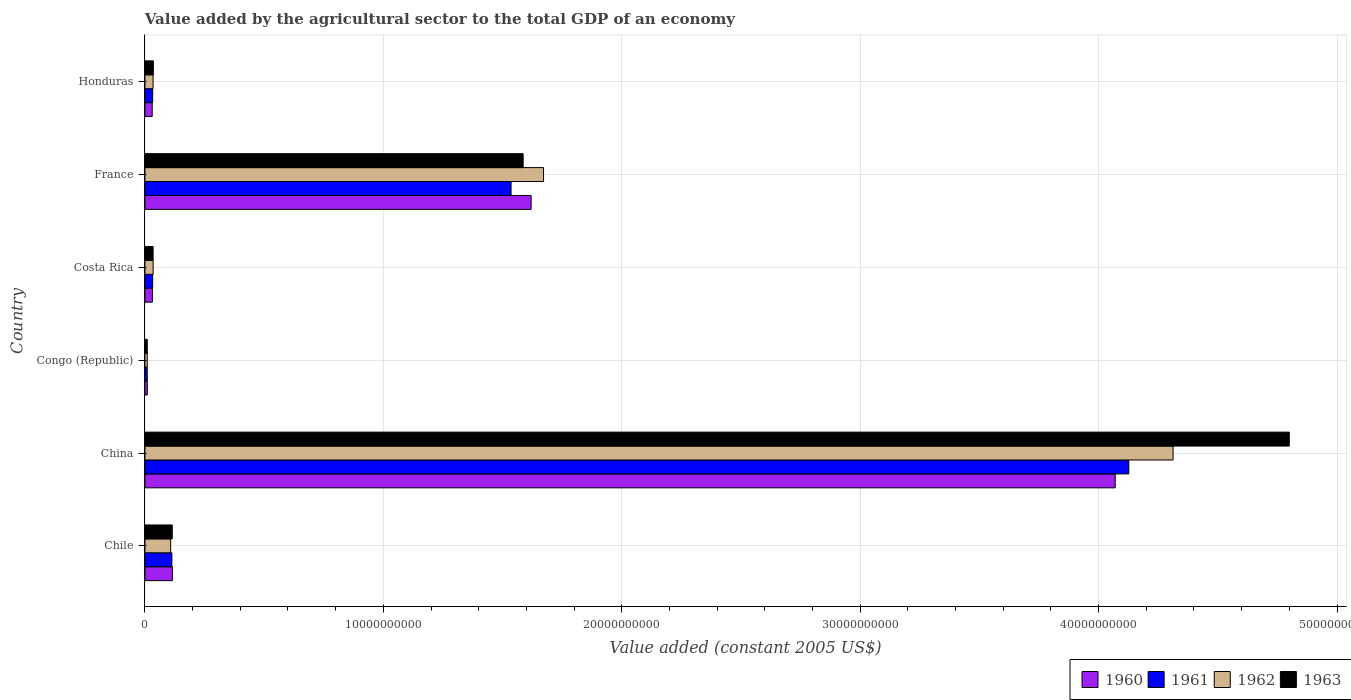Are the number of bars on each tick of the Y-axis equal?
Provide a short and direct response. Yes. How many bars are there on the 5th tick from the top?
Provide a succinct answer. 4. What is the label of the 5th group of bars from the top?
Provide a succinct answer. China. In how many cases, is the number of bars for a given country not equal to the number of legend labels?
Provide a succinct answer. 0. What is the value added by the agricultural sector in 1963 in Chile?
Your answer should be compact. 1.15e+09. Across all countries, what is the maximum value added by the agricultural sector in 1960?
Make the answer very short. 4.07e+1. Across all countries, what is the minimum value added by the agricultural sector in 1963?
Your answer should be very brief. 9.86e+07. In which country was the value added by the agricultural sector in 1960 minimum?
Your response must be concise. Congo (Republic). What is the total value added by the agricultural sector in 1961 in the graph?
Make the answer very short. 5.85e+1. What is the difference between the value added by the agricultural sector in 1962 in China and that in Congo (Republic)?
Your response must be concise. 4.30e+1. What is the difference between the value added by the agricultural sector in 1961 in Congo (Republic) and the value added by the agricultural sector in 1960 in Honduras?
Keep it short and to the point. -2.08e+08. What is the average value added by the agricultural sector in 1961 per country?
Offer a terse response. 9.75e+09. What is the difference between the value added by the agricultural sector in 1961 and value added by the agricultural sector in 1962 in Costa Rica?
Your answer should be compact. -1.99e+07. What is the ratio of the value added by the agricultural sector in 1960 in Costa Rica to that in France?
Ensure brevity in your answer.  0.02. What is the difference between the highest and the second highest value added by the agricultural sector in 1963?
Ensure brevity in your answer.  3.21e+1. What is the difference between the highest and the lowest value added by the agricultural sector in 1961?
Give a very brief answer. 4.12e+1. Is it the case that in every country, the sum of the value added by the agricultural sector in 1961 and value added by the agricultural sector in 1960 is greater than the sum of value added by the agricultural sector in 1963 and value added by the agricultural sector in 1962?
Provide a short and direct response. No. What does the 2nd bar from the top in Chile represents?
Ensure brevity in your answer.  1962. Is it the case that in every country, the sum of the value added by the agricultural sector in 1960 and value added by the agricultural sector in 1963 is greater than the value added by the agricultural sector in 1961?
Your answer should be very brief. Yes. How many bars are there?
Your response must be concise. 24. Are all the bars in the graph horizontal?
Your answer should be compact. Yes. Does the graph contain any zero values?
Offer a very short reply. No. How many legend labels are there?
Your response must be concise. 4. How are the legend labels stacked?
Offer a very short reply. Horizontal. What is the title of the graph?
Your answer should be compact. Value added by the agricultural sector to the total GDP of an economy. Does "1971" appear as one of the legend labels in the graph?
Your answer should be very brief. No. What is the label or title of the X-axis?
Your answer should be very brief. Value added (constant 2005 US$). What is the Value added (constant 2005 US$) in 1960 in Chile?
Your answer should be compact. 1.15e+09. What is the Value added (constant 2005 US$) of 1961 in Chile?
Ensure brevity in your answer.  1.13e+09. What is the Value added (constant 2005 US$) in 1962 in Chile?
Your response must be concise. 1.08e+09. What is the Value added (constant 2005 US$) in 1963 in Chile?
Give a very brief answer. 1.15e+09. What is the Value added (constant 2005 US$) in 1960 in China?
Keep it short and to the point. 4.07e+1. What is the Value added (constant 2005 US$) of 1961 in China?
Ensure brevity in your answer.  4.13e+1. What is the Value added (constant 2005 US$) of 1962 in China?
Offer a very short reply. 4.31e+1. What is the Value added (constant 2005 US$) in 1963 in China?
Offer a terse response. 4.80e+1. What is the Value added (constant 2005 US$) in 1960 in Congo (Republic)?
Offer a very short reply. 1.01e+08. What is the Value added (constant 2005 US$) of 1961 in Congo (Republic)?
Offer a very short reply. 9.74e+07. What is the Value added (constant 2005 US$) in 1962 in Congo (Republic)?
Offer a very short reply. 9.79e+07. What is the Value added (constant 2005 US$) of 1963 in Congo (Republic)?
Make the answer very short. 9.86e+07. What is the Value added (constant 2005 US$) in 1960 in Costa Rica?
Your answer should be very brief. 3.13e+08. What is the Value added (constant 2005 US$) of 1961 in Costa Rica?
Offer a terse response. 3.24e+08. What is the Value added (constant 2005 US$) in 1962 in Costa Rica?
Make the answer very short. 3.44e+08. What is the Value added (constant 2005 US$) of 1963 in Costa Rica?
Your answer should be very brief. 3.43e+08. What is the Value added (constant 2005 US$) of 1960 in France?
Your answer should be very brief. 1.62e+1. What is the Value added (constant 2005 US$) of 1961 in France?
Give a very brief answer. 1.54e+1. What is the Value added (constant 2005 US$) of 1962 in France?
Your answer should be compact. 1.67e+1. What is the Value added (constant 2005 US$) of 1963 in France?
Offer a terse response. 1.59e+1. What is the Value added (constant 2005 US$) in 1960 in Honduras?
Provide a succinct answer. 3.05e+08. What is the Value added (constant 2005 US$) of 1961 in Honduras?
Provide a short and direct response. 3.25e+08. What is the Value added (constant 2005 US$) of 1962 in Honduras?
Provide a short and direct response. 3.41e+08. What is the Value added (constant 2005 US$) in 1963 in Honduras?
Make the answer very short. 3.53e+08. Across all countries, what is the maximum Value added (constant 2005 US$) in 1960?
Offer a terse response. 4.07e+1. Across all countries, what is the maximum Value added (constant 2005 US$) of 1961?
Keep it short and to the point. 4.13e+1. Across all countries, what is the maximum Value added (constant 2005 US$) in 1962?
Offer a terse response. 4.31e+1. Across all countries, what is the maximum Value added (constant 2005 US$) of 1963?
Give a very brief answer. 4.80e+1. Across all countries, what is the minimum Value added (constant 2005 US$) of 1960?
Make the answer very short. 1.01e+08. Across all countries, what is the minimum Value added (constant 2005 US$) of 1961?
Offer a terse response. 9.74e+07. Across all countries, what is the minimum Value added (constant 2005 US$) of 1962?
Give a very brief answer. 9.79e+07. Across all countries, what is the minimum Value added (constant 2005 US$) of 1963?
Your response must be concise. 9.86e+07. What is the total Value added (constant 2005 US$) of 1960 in the graph?
Your answer should be compact. 5.88e+1. What is the total Value added (constant 2005 US$) of 1961 in the graph?
Keep it short and to the point. 5.85e+1. What is the total Value added (constant 2005 US$) of 1962 in the graph?
Your answer should be very brief. 6.17e+1. What is the total Value added (constant 2005 US$) in 1963 in the graph?
Provide a succinct answer. 6.58e+1. What is the difference between the Value added (constant 2005 US$) in 1960 in Chile and that in China?
Provide a succinct answer. -3.95e+1. What is the difference between the Value added (constant 2005 US$) of 1961 in Chile and that in China?
Your answer should be compact. -4.01e+1. What is the difference between the Value added (constant 2005 US$) in 1962 in Chile and that in China?
Make the answer very short. -4.20e+1. What is the difference between the Value added (constant 2005 US$) of 1963 in Chile and that in China?
Make the answer very short. -4.69e+1. What is the difference between the Value added (constant 2005 US$) of 1960 in Chile and that in Congo (Republic)?
Provide a short and direct response. 1.05e+09. What is the difference between the Value added (constant 2005 US$) of 1961 in Chile and that in Congo (Republic)?
Keep it short and to the point. 1.03e+09. What is the difference between the Value added (constant 2005 US$) of 1962 in Chile and that in Congo (Republic)?
Provide a short and direct response. 9.81e+08. What is the difference between the Value added (constant 2005 US$) in 1963 in Chile and that in Congo (Republic)?
Keep it short and to the point. 1.05e+09. What is the difference between the Value added (constant 2005 US$) in 1960 in Chile and that in Costa Rica?
Your answer should be very brief. 8.39e+08. What is the difference between the Value added (constant 2005 US$) of 1961 in Chile and that in Costa Rica?
Keep it short and to the point. 8.06e+08. What is the difference between the Value added (constant 2005 US$) of 1962 in Chile and that in Costa Rica?
Give a very brief answer. 7.35e+08. What is the difference between the Value added (constant 2005 US$) in 1963 in Chile and that in Costa Rica?
Your response must be concise. 8.03e+08. What is the difference between the Value added (constant 2005 US$) in 1960 in Chile and that in France?
Ensure brevity in your answer.  -1.50e+1. What is the difference between the Value added (constant 2005 US$) in 1961 in Chile and that in France?
Your answer should be very brief. -1.42e+1. What is the difference between the Value added (constant 2005 US$) of 1962 in Chile and that in France?
Your response must be concise. -1.56e+1. What is the difference between the Value added (constant 2005 US$) in 1963 in Chile and that in France?
Offer a very short reply. -1.47e+1. What is the difference between the Value added (constant 2005 US$) of 1960 in Chile and that in Honduras?
Make the answer very short. 8.46e+08. What is the difference between the Value added (constant 2005 US$) in 1961 in Chile and that in Honduras?
Ensure brevity in your answer.  8.05e+08. What is the difference between the Value added (constant 2005 US$) of 1962 in Chile and that in Honduras?
Ensure brevity in your answer.  7.38e+08. What is the difference between the Value added (constant 2005 US$) of 1963 in Chile and that in Honduras?
Keep it short and to the point. 7.93e+08. What is the difference between the Value added (constant 2005 US$) in 1960 in China and that in Congo (Republic)?
Your response must be concise. 4.06e+1. What is the difference between the Value added (constant 2005 US$) in 1961 in China and that in Congo (Republic)?
Keep it short and to the point. 4.12e+1. What is the difference between the Value added (constant 2005 US$) in 1962 in China and that in Congo (Republic)?
Provide a succinct answer. 4.30e+1. What is the difference between the Value added (constant 2005 US$) of 1963 in China and that in Congo (Republic)?
Offer a very short reply. 4.79e+1. What is the difference between the Value added (constant 2005 US$) in 1960 in China and that in Costa Rica?
Give a very brief answer. 4.04e+1. What is the difference between the Value added (constant 2005 US$) of 1961 in China and that in Costa Rica?
Offer a terse response. 4.09e+1. What is the difference between the Value added (constant 2005 US$) in 1962 in China and that in Costa Rica?
Ensure brevity in your answer.  4.28e+1. What is the difference between the Value added (constant 2005 US$) in 1963 in China and that in Costa Rica?
Your answer should be very brief. 4.77e+1. What is the difference between the Value added (constant 2005 US$) of 1960 in China and that in France?
Your answer should be compact. 2.45e+1. What is the difference between the Value added (constant 2005 US$) of 1961 in China and that in France?
Make the answer very short. 2.59e+1. What is the difference between the Value added (constant 2005 US$) of 1962 in China and that in France?
Your answer should be compact. 2.64e+1. What is the difference between the Value added (constant 2005 US$) in 1963 in China and that in France?
Your response must be concise. 3.21e+1. What is the difference between the Value added (constant 2005 US$) of 1960 in China and that in Honduras?
Keep it short and to the point. 4.04e+1. What is the difference between the Value added (constant 2005 US$) in 1961 in China and that in Honduras?
Make the answer very short. 4.09e+1. What is the difference between the Value added (constant 2005 US$) of 1962 in China and that in Honduras?
Ensure brevity in your answer.  4.28e+1. What is the difference between the Value added (constant 2005 US$) of 1963 in China and that in Honduras?
Provide a short and direct response. 4.76e+1. What is the difference between the Value added (constant 2005 US$) in 1960 in Congo (Republic) and that in Costa Rica?
Provide a short and direct response. -2.12e+08. What is the difference between the Value added (constant 2005 US$) in 1961 in Congo (Republic) and that in Costa Rica?
Make the answer very short. -2.27e+08. What is the difference between the Value added (constant 2005 US$) of 1962 in Congo (Republic) and that in Costa Rica?
Provide a succinct answer. -2.46e+08. What is the difference between the Value added (constant 2005 US$) of 1963 in Congo (Republic) and that in Costa Rica?
Your response must be concise. -2.45e+08. What is the difference between the Value added (constant 2005 US$) in 1960 in Congo (Republic) and that in France?
Offer a very short reply. -1.61e+1. What is the difference between the Value added (constant 2005 US$) of 1961 in Congo (Republic) and that in France?
Keep it short and to the point. -1.53e+1. What is the difference between the Value added (constant 2005 US$) of 1962 in Congo (Republic) and that in France?
Give a very brief answer. -1.66e+1. What is the difference between the Value added (constant 2005 US$) in 1963 in Congo (Republic) and that in France?
Provide a short and direct response. -1.58e+1. What is the difference between the Value added (constant 2005 US$) of 1960 in Congo (Republic) and that in Honduras?
Offer a very short reply. -2.04e+08. What is the difference between the Value added (constant 2005 US$) of 1961 in Congo (Republic) and that in Honduras?
Offer a very short reply. -2.28e+08. What is the difference between the Value added (constant 2005 US$) of 1962 in Congo (Republic) and that in Honduras?
Offer a terse response. -2.43e+08. What is the difference between the Value added (constant 2005 US$) in 1963 in Congo (Republic) and that in Honduras?
Keep it short and to the point. -2.55e+08. What is the difference between the Value added (constant 2005 US$) of 1960 in Costa Rica and that in France?
Make the answer very short. -1.59e+1. What is the difference between the Value added (constant 2005 US$) in 1961 in Costa Rica and that in France?
Ensure brevity in your answer.  -1.50e+1. What is the difference between the Value added (constant 2005 US$) in 1962 in Costa Rica and that in France?
Your answer should be compact. -1.64e+1. What is the difference between the Value added (constant 2005 US$) in 1963 in Costa Rica and that in France?
Your response must be concise. -1.55e+1. What is the difference between the Value added (constant 2005 US$) of 1960 in Costa Rica and that in Honduras?
Provide a short and direct response. 7.61e+06. What is the difference between the Value added (constant 2005 US$) of 1961 in Costa Rica and that in Honduras?
Offer a terse response. -8.14e+05. What is the difference between the Value added (constant 2005 US$) of 1962 in Costa Rica and that in Honduras?
Offer a terse response. 3.61e+06. What is the difference between the Value added (constant 2005 US$) in 1963 in Costa Rica and that in Honduras?
Your response must be concise. -9.78e+06. What is the difference between the Value added (constant 2005 US$) in 1960 in France and that in Honduras?
Keep it short and to the point. 1.59e+1. What is the difference between the Value added (constant 2005 US$) in 1961 in France and that in Honduras?
Provide a succinct answer. 1.50e+1. What is the difference between the Value added (constant 2005 US$) in 1962 in France and that in Honduras?
Keep it short and to the point. 1.64e+1. What is the difference between the Value added (constant 2005 US$) of 1963 in France and that in Honduras?
Ensure brevity in your answer.  1.55e+1. What is the difference between the Value added (constant 2005 US$) in 1960 in Chile and the Value added (constant 2005 US$) in 1961 in China?
Offer a very short reply. -4.01e+1. What is the difference between the Value added (constant 2005 US$) in 1960 in Chile and the Value added (constant 2005 US$) in 1962 in China?
Ensure brevity in your answer.  -4.20e+1. What is the difference between the Value added (constant 2005 US$) of 1960 in Chile and the Value added (constant 2005 US$) of 1963 in China?
Make the answer very short. -4.68e+1. What is the difference between the Value added (constant 2005 US$) in 1961 in Chile and the Value added (constant 2005 US$) in 1962 in China?
Offer a terse response. -4.20e+1. What is the difference between the Value added (constant 2005 US$) in 1961 in Chile and the Value added (constant 2005 US$) in 1963 in China?
Your answer should be very brief. -4.69e+1. What is the difference between the Value added (constant 2005 US$) in 1962 in Chile and the Value added (constant 2005 US$) in 1963 in China?
Your answer should be very brief. -4.69e+1. What is the difference between the Value added (constant 2005 US$) in 1960 in Chile and the Value added (constant 2005 US$) in 1961 in Congo (Republic)?
Your response must be concise. 1.05e+09. What is the difference between the Value added (constant 2005 US$) in 1960 in Chile and the Value added (constant 2005 US$) in 1962 in Congo (Republic)?
Provide a succinct answer. 1.05e+09. What is the difference between the Value added (constant 2005 US$) of 1960 in Chile and the Value added (constant 2005 US$) of 1963 in Congo (Republic)?
Provide a short and direct response. 1.05e+09. What is the difference between the Value added (constant 2005 US$) in 1961 in Chile and the Value added (constant 2005 US$) in 1962 in Congo (Republic)?
Your answer should be compact. 1.03e+09. What is the difference between the Value added (constant 2005 US$) in 1961 in Chile and the Value added (constant 2005 US$) in 1963 in Congo (Republic)?
Give a very brief answer. 1.03e+09. What is the difference between the Value added (constant 2005 US$) in 1962 in Chile and the Value added (constant 2005 US$) in 1963 in Congo (Republic)?
Your response must be concise. 9.81e+08. What is the difference between the Value added (constant 2005 US$) of 1960 in Chile and the Value added (constant 2005 US$) of 1961 in Costa Rica?
Keep it short and to the point. 8.27e+08. What is the difference between the Value added (constant 2005 US$) of 1960 in Chile and the Value added (constant 2005 US$) of 1962 in Costa Rica?
Your answer should be very brief. 8.07e+08. What is the difference between the Value added (constant 2005 US$) in 1960 in Chile and the Value added (constant 2005 US$) in 1963 in Costa Rica?
Make the answer very short. 8.08e+08. What is the difference between the Value added (constant 2005 US$) of 1961 in Chile and the Value added (constant 2005 US$) of 1962 in Costa Rica?
Provide a succinct answer. 7.86e+08. What is the difference between the Value added (constant 2005 US$) in 1961 in Chile and the Value added (constant 2005 US$) in 1963 in Costa Rica?
Give a very brief answer. 7.87e+08. What is the difference between the Value added (constant 2005 US$) in 1962 in Chile and the Value added (constant 2005 US$) in 1963 in Costa Rica?
Provide a short and direct response. 7.36e+08. What is the difference between the Value added (constant 2005 US$) of 1960 in Chile and the Value added (constant 2005 US$) of 1961 in France?
Offer a very short reply. -1.42e+1. What is the difference between the Value added (constant 2005 US$) in 1960 in Chile and the Value added (constant 2005 US$) in 1962 in France?
Give a very brief answer. -1.56e+1. What is the difference between the Value added (constant 2005 US$) of 1960 in Chile and the Value added (constant 2005 US$) of 1963 in France?
Your answer should be very brief. -1.47e+1. What is the difference between the Value added (constant 2005 US$) of 1961 in Chile and the Value added (constant 2005 US$) of 1962 in France?
Provide a succinct answer. -1.56e+1. What is the difference between the Value added (constant 2005 US$) in 1961 in Chile and the Value added (constant 2005 US$) in 1963 in France?
Your answer should be compact. -1.47e+1. What is the difference between the Value added (constant 2005 US$) of 1962 in Chile and the Value added (constant 2005 US$) of 1963 in France?
Give a very brief answer. -1.48e+1. What is the difference between the Value added (constant 2005 US$) in 1960 in Chile and the Value added (constant 2005 US$) in 1961 in Honduras?
Provide a short and direct response. 8.27e+08. What is the difference between the Value added (constant 2005 US$) in 1960 in Chile and the Value added (constant 2005 US$) in 1962 in Honduras?
Your response must be concise. 8.11e+08. What is the difference between the Value added (constant 2005 US$) of 1960 in Chile and the Value added (constant 2005 US$) of 1963 in Honduras?
Your answer should be compact. 7.99e+08. What is the difference between the Value added (constant 2005 US$) of 1961 in Chile and the Value added (constant 2005 US$) of 1962 in Honduras?
Provide a short and direct response. 7.90e+08. What is the difference between the Value added (constant 2005 US$) of 1961 in Chile and the Value added (constant 2005 US$) of 1963 in Honduras?
Provide a succinct answer. 7.78e+08. What is the difference between the Value added (constant 2005 US$) of 1962 in Chile and the Value added (constant 2005 US$) of 1963 in Honduras?
Ensure brevity in your answer.  7.26e+08. What is the difference between the Value added (constant 2005 US$) in 1960 in China and the Value added (constant 2005 US$) in 1961 in Congo (Republic)?
Keep it short and to the point. 4.06e+1. What is the difference between the Value added (constant 2005 US$) of 1960 in China and the Value added (constant 2005 US$) of 1962 in Congo (Republic)?
Your answer should be compact. 4.06e+1. What is the difference between the Value added (constant 2005 US$) in 1960 in China and the Value added (constant 2005 US$) in 1963 in Congo (Republic)?
Give a very brief answer. 4.06e+1. What is the difference between the Value added (constant 2005 US$) in 1961 in China and the Value added (constant 2005 US$) in 1962 in Congo (Republic)?
Provide a succinct answer. 4.12e+1. What is the difference between the Value added (constant 2005 US$) of 1961 in China and the Value added (constant 2005 US$) of 1963 in Congo (Republic)?
Ensure brevity in your answer.  4.12e+1. What is the difference between the Value added (constant 2005 US$) in 1962 in China and the Value added (constant 2005 US$) in 1963 in Congo (Republic)?
Ensure brevity in your answer.  4.30e+1. What is the difference between the Value added (constant 2005 US$) in 1960 in China and the Value added (constant 2005 US$) in 1961 in Costa Rica?
Make the answer very short. 4.04e+1. What is the difference between the Value added (constant 2005 US$) in 1960 in China and the Value added (constant 2005 US$) in 1962 in Costa Rica?
Your answer should be very brief. 4.04e+1. What is the difference between the Value added (constant 2005 US$) in 1960 in China and the Value added (constant 2005 US$) in 1963 in Costa Rica?
Your answer should be very brief. 4.04e+1. What is the difference between the Value added (constant 2005 US$) in 1961 in China and the Value added (constant 2005 US$) in 1962 in Costa Rica?
Give a very brief answer. 4.09e+1. What is the difference between the Value added (constant 2005 US$) in 1961 in China and the Value added (constant 2005 US$) in 1963 in Costa Rica?
Offer a terse response. 4.09e+1. What is the difference between the Value added (constant 2005 US$) of 1962 in China and the Value added (constant 2005 US$) of 1963 in Costa Rica?
Your answer should be compact. 4.28e+1. What is the difference between the Value added (constant 2005 US$) of 1960 in China and the Value added (constant 2005 US$) of 1961 in France?
Keep it short and to the point. 2.53e+1. What is the difference between the Value added (constant 2005 US$) of 1960 in China and the Value added (constant 2005 US$) of 1962 in France?
Your answer should be compact. 2.40e+1. What is the difference between the Value added (constant 2005 US$) of 1960 in China and the Value added (constant 2005 US$) of 1963 in France?
Provide a short and direct response. 2.48e+1. What is the difference between the Value added (constant 2005 US$) in 1961 in China and the Value added (constant 2005 US$) in 1962 in France?
Your answer should be very brief. 2.45e+1. What is the difference between the Value added (constant 2005 US$) in 1961 in China and the Value added (constant 2005 US$) in 1963 in France?
Provide a short and direct response. 2.54e+1. What is the difference between the Value added (constant 2005 US$) in 1962 in China and the Value added (constant 2005 US$) in 1963 in France?
Provide a short and direct response. 2.73e+1. What is the difference between the Value added (constant 2005 US$) of 1960 in China and the Value added (constant 2005 US$) of 1961 in Honduras?
Your answer should be compact. 4.04e+1. What is the difference between the Value added (constant 2005 US$) in 1960 in China and the Value added (constant 2005 US$) in 1962 in Honduras?
Your response must be concise. 4.04e+1. What is the difference between the Value added (constant 2005 US$) in 1960 in China and the Value added (constant 2005 US$) in 1963 in Honduras?
Offer a terse response. 4.03e+1. What is the difference between the Value added (constant 2005 US$) of 1961 in China and the Value added (constant 2005 US$) of 1962 in Honduras?
Keep it short and to the point. 4.09e+1. What is the difference between the Value added (constant 2005 US$) in 1961 in China and the Value added (constant 2005 US$) in 1963 in Honduras?
Provide a short and direct response. 4.09e+1. What is the difference between the Value added (constant 2005 US$) of 1962 in China and the Value added (constant 2005 US$) of 1963 in Honduras?
Offer a very short reply. 4.28e+1. What is the difference between the Value added (constant 2005 US$) of 1960 in Congo (Republic) and the Value added (constant 2005 US$) of 1961 in Costa Rica?
Your answer should be very brief. -2.24e+08. What is the difference between the Value added (constant 2005 US$) in 1960 in Congo (Republic) and the Value added (constant 2005 US$) in 1962 in Costa Rica?
Your answer should be very brief. -2.43e+08. What is the difference between the Value added (constant 2005 US$) of 1960 in Congo (Republic) and the Value added (constant 2005 US$) of 1963 in Costa Rica?
Your response must be concise. -2.42e+08. What is the difference between the Value added (constant 2005 US$) in 1961 in Congo (Republic) and the Value added (constant 2005 US$) in 1962 in Costa Rica?
Provide a succinct answer. -2.47e+08. What is the difference between the Value added (constant 2005 US$) in 1961 in Congo (Republic) and the Value added (constant 2005 US$) in 1963 in Costa Rica?
Give a very brief answer. -2.46e+08. What is the difference between the Value added (constant 2005 US$) in 1962 in Congo (Republic) and the Value added (constant 2005 US$) in 1963 in Costa Rica?
Offer a very short reply. -2.45e+08. What is the difference between the Value added (constant 2005 US$) in 1960 in Congo (Republic) and the Value added (constant 2005 US$) in 1961 in France?
Keep it short and to the point. -1.53e+1. What is the difference between the Value added (constant 2005 US$) of 1960 in Congo (Republic) and the Value added (constant 2005 US$) of 1962 in France?
Ensure brevity in your answer.  -1.66e+1. What is the difference between the Value added (constant 2005 US$) in 1960 in Congo (Republic) and the Value added (constant 2005 US$) in 1963 in France?
Give a very brief answer. -1.58e+1. What is the difference between the Value added (constant 2005 US$) in 1961 in Congo (Republic) and the Value added (constant 2005 US$) in 1962 in France?
Your response must be concise. -1.66e+1. What is the difference between the Value added (constant 2005 US$) in 1961 in Congo (Republic) and the Value added (constant 2005 US$) in 1963 in France?
Offer a terse response. -1.58e+1. What is the difference between the Value added (constant 2005 US$) of 1962 in Congo (Republic) and the Value added (constant 2005 US$) of 1963 in France?
Provide a short and direct response. -1.58e+1. What is the difference between the Value added (constant 2005 US$) in 1960 in Congo (Republic) and the Value added (constant 2005 US$) in 1961 in Honduras?
Keep it short and to the point. -2.24e+08. What is the difference between the Value added (constant 2005 US$) of 1960 in Congo (Republic) and the Value added (constant 2005 US$) of 1962 in Honduras?
Ensure brevity in your answer.  -2.40e+08. What is the difference between the Value added (constant 2005 US$) in 1960 in Congo (Republic) and the Value added (constant 2005 US$) in 1963 in Honduras?
Provide a short and direct response. -2.52e+08. What is the difference between the Value added (constant 2005 US$) of 1961 in Congo (Republic) and the Value added (constant 2005 US$) of 1962 in Honduras?
Your answer should be very brief. -2.43e+08. What is the difference between the Value added (constant 2005 US$) in 1961 in Congo (Republic) and the Value added (constant 2005 US$) in 1963 in Honduras?
Your answer should be very brief. -2.56e+08. What is the difference between the Value added (constant 2005 US$) of 1962 in Congo (Republic) and the Value added (constant 2005 US$) of 1963 in Honduras?
Your answer should be very brief. -2.55e+08. What is the difference between the Value added (constant 2005 US$) of 1960 in Costa Rica and the Value added (constant 2005 US$) of 1961 in France?
Provide a short and direct response. -1.50e+1. What is the difference between the Value added (constant 2005 US$) in 1960 in Costa Rica and the Value added (constant 2005 US$) in 1962 in France?
Your answer should be very brief. -1.64e+1. What is the difference between the Value added (constant 2005 US$) of 1960 in Costa Rica and the Value added (constant 2005 US$) of 1963 in France?
Your answer should be compact. -1.56e+1. What is the difference between the Value added (constant 2005 US$) in 1961 in Costa Rica and the Value added (constant 2005 US$) in 1962 in France?
Make the answer very short. -1.64e+1. What is the difference between the Value added (constant 2005 US$) in 1961 in Costa Rica and the Value added (constant 2005 US$) in 1963 in France?
Offer a very short reply. -1.55e+1. What is the difference between the Value added (constant 2005 US$) of 1962 in Costa Rica and the Value added (constant 2005 US$) of 1963 in France?
Ensure brevity in your answer.  -1.55e+1. What is the difference between the Value added (constant 2005 US$) of 1960 in Costa Rica and the Value added (constant 2005 US$) of 1961 in Honduras?
Provide a short and direct response. -1.23e+07. What is the difference between the Value added (constant 2005 US$) in 1960 in Costa Rica and the Value added (constant 2005 US$) in 1962 in Honduras?
Provide a short and direct response. -2.78e+07. What is the difference between the Value added (constant 2005 US$) of 1960 in Costa Rica and the Value added (constant 2005 US$) of 1963 in Honduras?
Provide a short and direct response. -4.02e+07. What is the difference between the Value added (constant 2005 US$) of 1961 in Costa Rica and the Value added (constant 2005 US$) of 1962 in Honduras?
Keep it short and to the point. -1.63e+07. What is the difference between the Value added (constant 2005 US$) of 1961 in Costa Rica and the Value added (constant 2005 US$) of 1963 in Honduras?
Make the answer very short. -2.87e+07. What is the difference between the Value added (constant 2005 US$) in 1962 in Costa Rica and the Value added (constant 2005 US$) in 1963 in Honduras?
Your answer should be compact. -8.78e+06. What is the difference between the Value added (constant 2005 US$) of 1960 in France and the Value added (constant 2005 US$) of 1961 in Honduras?
Offer a terse response. 1.59e+1. What is the difference between the Value added (constant 2005 US$) in 1960 in France and the Value added (constant 2005 US$) in 1962 in Honduras?
Give a very brief answer. 1.59e+1. What is the difference between the Value added (constant 2005 US$) in 1960 in France and the Value added (constant 2005 US$) in 1963 in Honduras?
Offer a very short reply. 1.58e+1. What is the difference between the Value added (constant 2005 US$) of 1961 in France and the Value added (constant 2005 US$) of 1962 in Honduras?
Offer a very short reply. 1.50e+1. What is the difference between the Value added (constant 2005 US$) in 1961 in France and the Value added (constant 2005 US$) in 1963 in Honduras?
Give a very brief answer. 1.50e+1. What is the difference between the Value added (constant 2005 US$) in 1962 in France and the Value added (constant 2005 US$) in 1963 in Honduras?
Make the answer very short. 1.64e+1. What is the average Value added (constant 2005 US$) of 1960 per country?
Ensure brevity in your answer.  9.79e+09. What is the average Value added (constant 2005 US$) of 1961 per country?
Offer a terse response. 9.75e+09. What is the average Value added (constant 2005 US$) in 1962 per country?
Your answer should be very brief. 1.03e+1. What is the average Value added (constant 2005 US$) of 1963 per country?
Provide a short and direct response. 1.10e+1. What is the difference between the Value added (constant 2005 US$) in 1960 and Value added (constant 2005 US$) in 1961 in Chile?
Offer a very short reply. 2.12e+07. What is the difference between the Value added (constant 2005 US$) in 1960 and Value added (constant 2005 US$) in 1962 in Chile?
Offer a terse response. 7.27e+07. What is the difference between the Value added (constant 2005 US$) in 1960 and Value added (constant 2005 US$) in 1963 in Chile?
Provide a short and direct response. 5.74e+06. What is the difference between the Value added (constant 2005 US$) of 1961 and Value added (constant 2005 US$) of 1962 in Chile?
Ensure brevity in your answer.  5.15e+07. What is the difference between the Value added (constant 2005 US$) of 1961 and Value added (constant 2005 US$) of 1963 in Chile?
Your response must be concise. -1.54e+07. What is the difference between the Value added (constant 2005 US$) of 1962 and Value added (constant 2005 US$) of 1963 in Chile?
Ensure brevity in your answer.  -6.69e+07. What is the difference between the Value added (constant 2005 US$) of 1960 and Value added (constant 2005 US$) of 1961 in China?
Your response must be concise. -5.70e+08. What is the difference between the Value added (constant 2005 US$) of 1960 and Value added (constant 2005 US$) of 1962 in China?
Give a very brief answer. -2.43e+09. What is the difference between the Value added (constant 2005 US$) of 1960 and Value added (constant 2005 US$) of 1963 in China?
Offer a terse response. -7.30e+09. What is the difference between the Value added (constant 2005 US$) in 1961 and Value added (constant 2005 US$) in 1962 in China?
Give a very brief answer. -1.86e+09. What is the difference between the Value added (constant 2005 US$) of 1961 and Value added (constant 2005 US$) of 1963 in China?
Offer a very short reply. -6.73e+09. What is the difference between the Value added (constant 2005 US$) in 1962 and Value added (constant 2005 US$) in 1963 in China?
Provide a short and direct response. -4.87e+09. What is the difference between the Value added (constant 2005 US$) of 1960 and Value added (constant 2005 US$) of 1961 in Congo (Republic)?
Make the answer very short. 3.61e+06. What is the difference between the Value added (constant 2005 US$) in 1960 and Value added (constant 2005 US$) in 1962 in Congo (Republic)?
Provide a succinct answer. 3.02e+06. What is the difference between the Value added (constant 2005 US$) in 1960 and Value added (constant 2005 US$) in 1963 in Congo (Republic)?
Offer a terse response. 2.34e+06. What is the difference between the Value added (constant 2005 US$) of 1961 and Value added (constant 2005 US$) of 1962 in Congo (Republic)?
Ensure brevity in your answer.  -5.86e+05. What is the difference between the Value added (constant 2005 US$) in 1961 and Value added (constant 2005 US$) in 1963 in Congo (Republic)?
Ensure brevity in your answer.  -1.27e+06. What is the difference between the Value added (constant 2005 US$) of 1962 and Value added (constant 2005 US$) of 1963 in Congo (Republic)?
Provide a succinct answer. -6.85e+05. What is the difference between the Value added (constant 2005 US$) in 1960 and Value added (constant 2005 US$) in 1961 in Costa Rica?
Make the answer very short. -1.15e+07. What is the difference between the Value added (constant 2005 US$) in 1960 and Value added (constant 2005 US$) in 1962 in Costa Rica?
Offer a terse response. -3.14e+07. What is the difference between the Value added (constant 2005 US$) in 1960 and Value added (constant 2005 US$) in 1963 in Costa Rica?
Give a very brief answer. -3.04e+07. What is the difference between the Value added (constant 2005 US$) of 1961 and Value added (constant 2005 US$) of 1962 in Costa Rica?
Provide a short and direct response. -1.99e+07. What is the difference between the Value added (constant 2005 US$) in 1961 and Value added (constant 2005 US$) in 1963 in Costa Rica?
Offer a very short reply. -1.89e+07. What is the difference between the Value added (constant 2005 US$) in 1962 and Value added (constant 2005 US$) in 1963 in Costa Rica?
Provide a succinct answer. 1.00e+06. What is the difference between the Value added (constant 2005 US$) in 1960 and Value added (constant 2005 US$) in 1961 in France?
Provide a short and direct response. 8.42e+08. What is the difference between the Value added (constant 2005 US$) of 1960 and Value added (constant 2005 US$) of 1962 in France?
Your answer should be very brief. -5.20e+08. What is the difference between the Value added (constant 2005 US$) of 1960 and Value added (constant 2005 US$) of 1963 in France?
Offer a terse response. 3.35e+08. What is the difference between the Value added (constant 2005 US$) in 1961 and Value added (constant 2005 US$) in 1962 in France?
Offer a very short reply. -1.36e+09. What is the difference between the Value added (constant 2005 US$) in 1961 and Value added (constant 2005 US$) in 1963 in France?
Ensure brevity in your answer.  -5.07e+08. What is the difference between the Value added (constant 2005 US$) in 1962 and Value added (constant 2005 US$) in 1963 in France?
Your response must be concise. 8.56e+08. What is the difference between the Value added (constant 2005 US$) of 1960 and Value added (constant 2005 US$) of 1961 in Honduras?
Provide a short and direct response. -1.99e+07. What is the difference between the Value added (constant 2005 US$) of 1960 and Value added (constant 2005 US$) of 1962 in Honduras?
Give a very brief answer. -3.54e+07. What is the difference between the Value added (constant 2005 US$) in 1960 and Value added (constant 2005 US$) in 1963 in Honduras?
Offer a very short reply. -4.78e+07. What is the difference between the Value added (constant 2005 US$) of 1961 and Value added (constant 2005 US$) of 1962 in Honduras?
Provide a succinct answer. -1.55e+07. What is the difference between the Value added (constant 2005 US$) of 1961 and Value added (constant 2005 US$) of 1963 in Honduras?
Provide a succinct answer. -2.79e+07. What is the difference between the Value added (constant 2005 US$) of 1962 and Value added (constant 2005 US$) of 1963 in Honduras?
Offer a terse response. -1.24e+07. What is the ratio of the Value added (constant 2005 US$) of 1960 in Chile to that in China?
Your answer should be compact. 0.03. What is the ratio of the Value added (constant 2005 US$) of 1961 in Chile to that in China?
Make the answer very short. 0.03. What is the ratio of the Value added (constant 2005 US$) in 1962 in Chile to that in China?
Provide a succinct answer. 0.03. What is the ratio of the Value added (constant 2005 US$) in 1963 in Chile to that in China?
Your answer should be very brief. 0.02. What is the ratio of the Value added (constant 2005 US$) in 1960 in Chile to that in Congo (Republic)?
Provide a succinct answer. 11.41. What is the ratio of the Value added (constant 2005 US$) of 1961 in Chile to that in Congo (Republic)?
Your answer should be compact. 11.61. What is the ratio of the Value added (constant 2005 US$) of 1962 in Chile to that in Congo (Republic)?
Your answer should be very brief. 11.02. What is the ratio of the Value added (constant 2005 US$) of 1963 in Chile to that in Congo (Republic)?
Provide a succinct answer. 11.62. What is the ratio of the Value added (constant 2005 US$) of 1960 in Chile to that in Costa Rica?
Give a very brief answer. 3.68. What is the ratio of the Value added (constant 2005 US$) in 1961 in Chile to that in Costa Rica?
Your response must be concise. 3.48. What is the ratio of the Value added (constant 2005 US$) in 1962 in Chile to that in Costa Rica?
Give a very brief answer. 3.13. What is the ratio of the Value added (constant 2005 US$) in 1963 in Chile to that in Costa Rica?
Give a very brief answer. 3.34. What is the ratio of the Value added (constant 2005 US$) of 1960 in Chile to that in France?
Offer a terse response. 0.07. What is the ratio of the Value added (constant 2005 US$) in 1961 in Chile to that in France?
Provide a short and direct response. 0.07. What is the ratio of the Value added (constant 2005 US$) in 1962 in Chile to that in France?
Ensure brevity in your answer.  0.06. What is the ratio of the Value added (constant 2005 US$) in 1963 in Chile to that in France?
Provide a succinct answer. 0.07. What is the ratio of the Value added (constant 2005 US$) in 1960 in Chile to that in Honduras?
Provide a short and direct response. 3.77. What is the ratio of the Value added (constant 2005 US$) in 1961 in Chile to that in Honduras?
Make the answer very short. 3.48. What is the ratio of the Value added (constant 2005 US$) of 1962 in Chile to that in Honduras?
Provide a succinct answer. 3.17. What is the ratio of the Value added (constant 2005 US$) of 1963 in Chile to that in Honduras?
Your response must be concise. 3.25. What is the ratio of the Value added (constant 2005 US$) in 1960 in China to that in Congo (Republic)?
Make the answer very short. 403.12. What is the ratio of the Value added (constant 2005 US$) in 1961 in China to that in Congo (Republic)?
Your answer should be compact. 423.9. What is the ratio of the Value added (constant 2005 US$) in 1962 in China to that in Congo (Republic)?
Offer a very short reply. 440.32. What is the ratio of the Value added (constant 2005 US$) of 1963 in China to that in Congo (Republic)?
Your answer should be very brief. 486.68. What is the ratio of the Value added (constant 2005 US$) in 1960 in China to that in Costa Rica?
Provide a succinct answer. 130.03. What is the ratio of the Value added (constant 2005 US$) of 1961 in China to that in Costa Rica?
Your response must be concise. 127.18. What is the ratio of the Value added (constant 2005 US$) of 1962 in China to that in Costa Rica?
Offer a terse response. 125.23. What is the ratio of the Value added (constant 2005 US$) of 1963 in China to that in Costa Rica?
Offer a terse response. 139.78. What is the ratio of the Value added (constant 2005 US$) of 1960 in China to that in France?
Your answer should be compact. 2.51. What is the ratio of the Value added (constant 2005 US$) in 1961 in China to that in France?
Your response must be concise. 2.69. What is the ratio of the Value added (constant 2005 US$) in 1962 in China to that in France?
Your answer should be compact. 2.58. What is the ratio of the Value added (constant 2005 US$) of 1963 in China to that in France?
Provide a short and direct response. 3.03. What is the ratio of the Value added (constant 2005 US$) of 1960 in China to that in Honduras?
Offer a terse response. 133.27. What is the ratio of the Value added (constant 2005 US$) in 1961 in China to that in Honduras?
Provide a succinct answer. 126.86. What is the ratio of the Value added (constant 2005 US$) in 1962 in China to that in Honduras?
Offer a very short reply. 126.55. What is the ratio of the Value added (constant 2005 US$) of 1963 in China to that in Honduras?
Your answer should be compact. 135.91. What is the ratio of the Value added (constant 2005 US$) of 1960 in Congo (Republic) to that in Costa Rica?
Provide a short and direct response. 0.32. What is the ratio of the Value added (constant 2005 US$) in 1962 in Congo (Republic) to that in Costa Rica?
Provide a succinct answer. 0.28. What is the ratio of the Value added (constant 2005 US$) of 1963 in Congo (Republic) to that in Costa Rica?
Offer a very short reply. 0.29. What is the ratio of the Value added (constant 2005 US$) of 1960 in Congo (Republic) to that in France?
Keep it short and to the point. 0.01. What is the ratio of the Value added (constant 2005 US$) in 1961 in Congo (Republic) to that in France?
Provide a succinct answer. 0.01. What is the ratio of the Value added (constant 2005 US$) of 1962 in Congo (Republic) to that in France?
Make the answer very short. 0.01. What is the ratio of the Value added (constant 2005 US$) in 1963 in Congo (Republic) to that in France?
Provide a short and direct response. 0.01. What is the ratio of the Value added (constant 2005 US$) in 1960 in Congo (Republic) to that in Honduras?
Your response must be concise. 0.33. What is the ratio of the Value added (constant 2005 US$) in 1961 in Congo (Republic) to that in Honduras?
Provide a short and direct response. 0.3. What is the ratio of the Value added (constant 2005 US$) in 1962 in Congo (Republic) to that in Honduras?
Make the answer very short. 0.29. What is the ratio of the Value added (constant 2005 US$) in 1963 in Congo (Republic) to that in Honduras?
Keep it short and to the point. 0.28. What is the ratio of the Value added (constant 2005 US$) in 1960 in Costa Rica to that in France?
Make the answer very short. 0.02. What is the ratio of the Value added (constant 2005 US$) of 1961 in Costa Rica to that in France?
Offer a very short reply. 0.02. What is the ratio of the Value added (constant 2005 US$) of 1962 in Costa Rica to that in France?
Your answer should be compact. 0.02. What is the ratio of the Value added (constant 2005 US$) of 1963 in Costa Rica to that in France?
Your response must be concise. 0.02. What is the ratio of the Value added (constant 2005 US$) in 1960 in Costa Rica to that in Honduras?
Keep it short and to the point. 1.02. What is the ratio of the Value added (constant 2005 US$) of 1962 in Costa Rica to that in Honduras?
Make the answer very short. 1.01. What is the ratio of the Value added (constant 2005 US$) in 1963 in Costa Rica to that in Honduras?
Offer a terse response. 0.97. What is the ratio of the Value added (constant 2005 US$) of 1960 in France to that in Honduras?
Keep it short and to the point. 53.05. What is the ratio of the Value added (constant 2005 US$) in 1961 in France to that in Honduras?
Ensure brevity in your answer.  47.21. What is the ratio of the Value added (constant 2005 US$) in 1962 in France to that in Honduras?
Provide a succinct answer. 49.07. What is the ratio of the Value added (constant 2005 US$) of 1963 in France to that in Honduras?
Provide a succinct answer. 44.92. What is the difference between the highest and the second highest Value added (constant 2005 US$) of 1960?
Offer a terse response. 2.45e+1. What is the difference between the highest and the second highest Value added (constant 2005 US$) of 1961?
Make the answer very short. 2.59e+1. What is the difference between the highest and the second highest Value added (constant 2005 US$) of 1962?
Offer a very short reply. 2.64e+1. What is the difference between the highest and the second highest Value added (constant 2005 US$) of 1963?
Provide a short and direct response. 3.21e+1. What is the difference between the highest and the lowest Value added (constant 2005 US$) of 1960?
Offer a very short reply. 4.06e+1. What is the difference between the highest and the lowest Value added (constant 2005 US$) of 1961?
Offer a very short reply. 4.12e+1. What is the difference between the highest and the lowest Value added (constant 2005 US$) of 1962?
Make the answer very short. 4.30e+1. What is the difference between the highest and the lowest Value added (constant 2005 US$) in 1963?
Keep it short and to the point. 4.79e+1. 